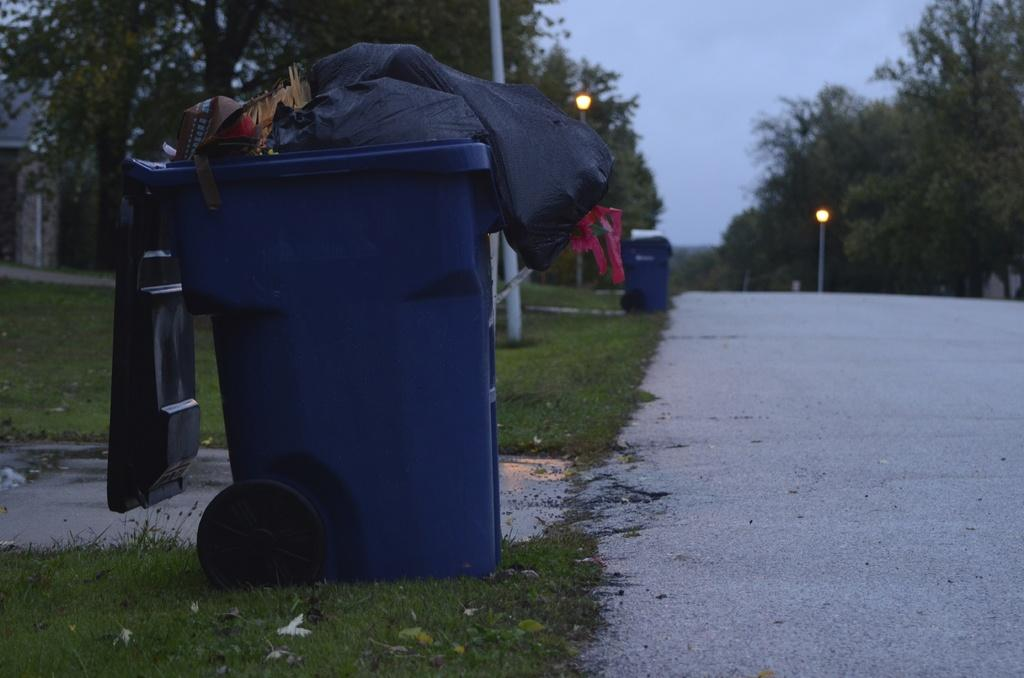What can be seen in the image that is used for waste disposal? There are dustbins filled with garbage in the image. What vertical structures are present in the image? There are poles in the image. What can be seen in the image that provides illumination? There are lights in the image. What type of vegetation is visible in the image? There are trees in the image. What is visible in the background of the image? The sky is visible in the background of the image. What substance is causing fear among the trees in the image? There is no indication of fear or any substance causing fear in the image; it features dustbins, poles, lights, trees, and a visible sky. Can you hear thunder in the image? There is no sound in the image, so it is not possible to determine if thunder can be heard. 